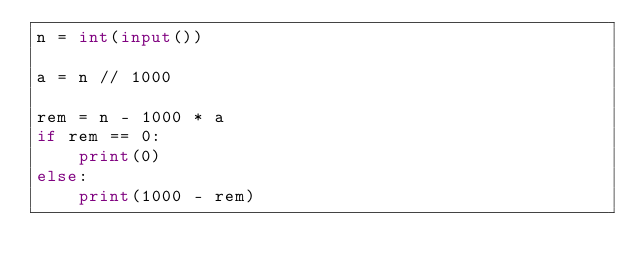Convert code to text. <code><loc_0><loc_0><loc_500><loc_500><_Python_>n = int(input())

a = n // 1000

rem = n - 1000 * a
if rem == 0:
    print(0)
else:
    print(1000 - rem)
</code> 